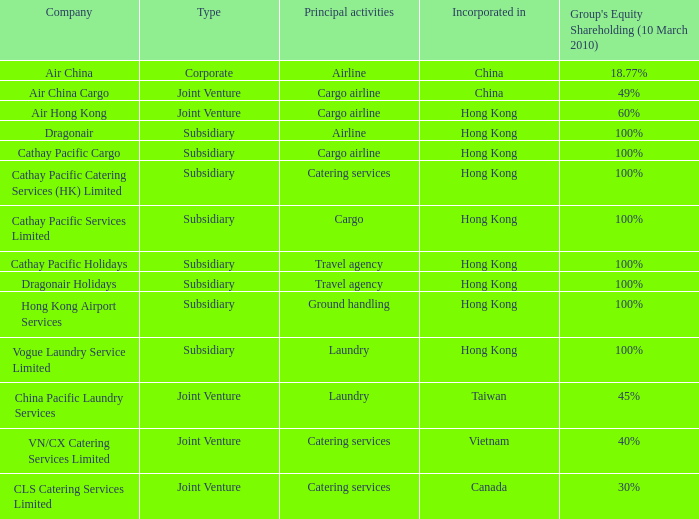As of march 10th, 2010, which company possessed a 30% equity shareholding percentage in a group? CLS Catering Services Limited. 